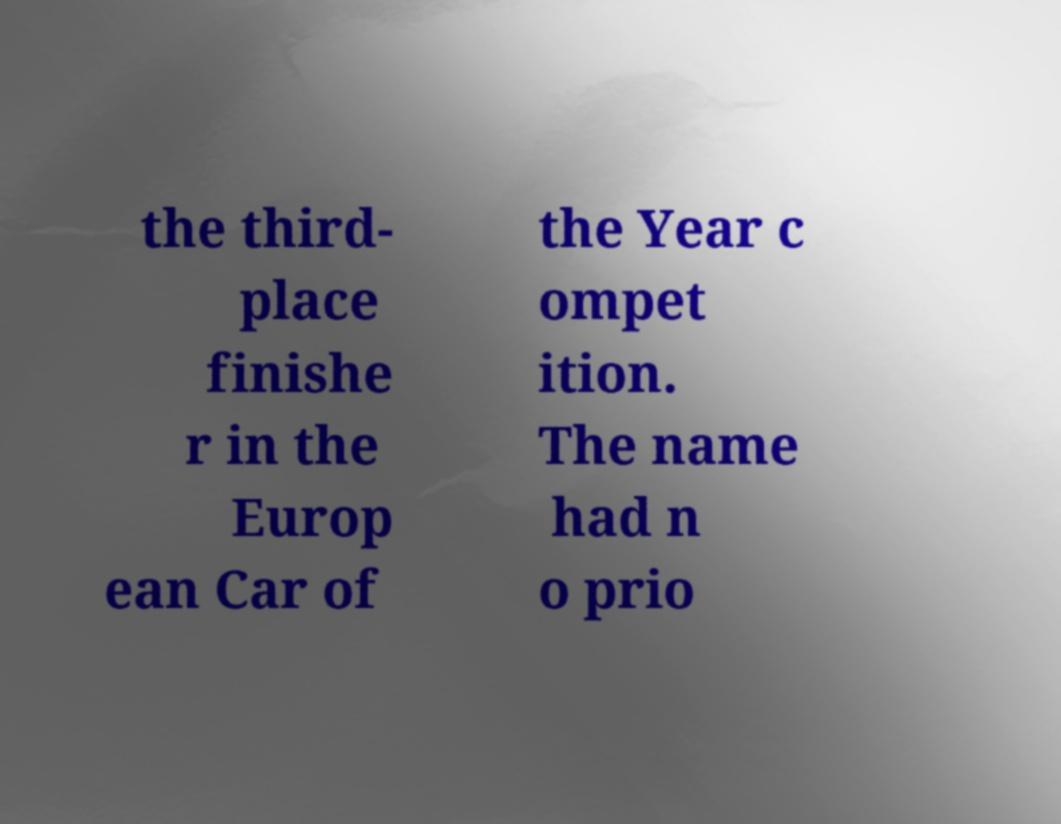Can you accurately transcribe the text from the provided image for me? the third- place finishe r in the Europ ean Car of the Year c ompet ition. The name had n o prio 